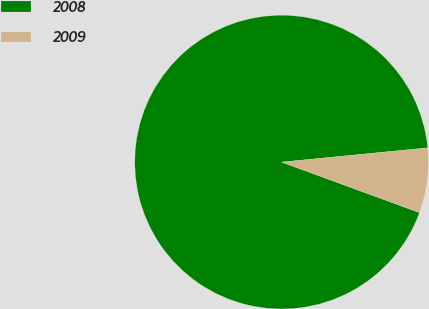Convert chart to OTSL. <chart><loc_0><loc_0><loc_500><loc_500><pie_chart><fcel>2008<fcel>2009<nl><fcel>92.86%<fcel>7.14%<nl></chart> 